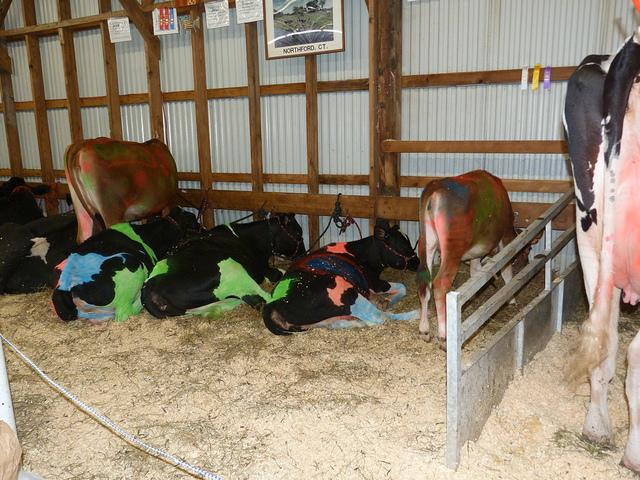What color is the black cow laying down to the right of the green cows?

Choices:
A) pink
B) blue
C) gold
D) silver pink 